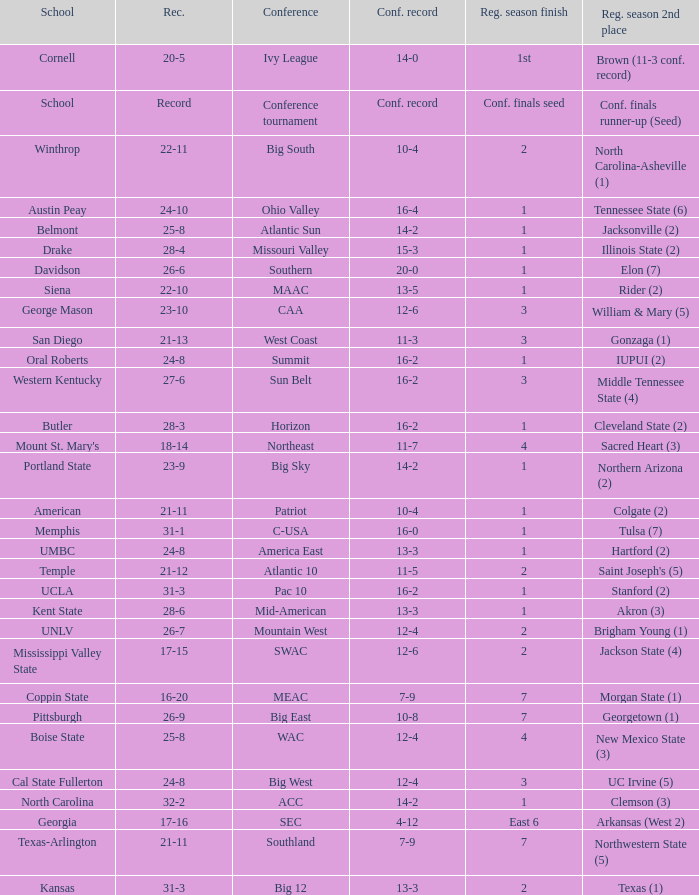For teams in the Sun Belt conference, what is the conference record? 16-2. Parse the full table. {'header': ['School', 'Rec.', 'Conference', 'Conf. record', 'Reg. season finish', 'Reg. season 2nd place'], 'rows': [['Cornell', '20-5', 'Ivy League', '14-0', '1st', 'Brown (11-3 conf. record)'], ['School', 'Record', 'Conference tournament', 'Conf. record', 'Conf. finals seed', 'Conf. finals runner-up (Seed)'], ['Winthrop', '22-11', 'Big South', '10-4', '2', 'North Carolina-Asheville (1)'], ['Austin Peay', '24-10', 'Ohio Valley', '16-4', '1', 'Tennessee State (6)'], ['Belmont', '25-8', 'Atlantic Sun', '14-2', '1', 'Jacksonville (2)'], ['Drake', '28-4', 'Missouri Valley', '15-3', '1', 'Illinois State (2)'], ['Davidson', '26-6', 'Southern', '20-0', '1', 'Elon (7)'], ['Siena', '22-10', 'MAAC', '13-5', '1', 'Rider (2)'], ['George Mason', '23-10', 'CAA', '12-6', '3', 'William & Mary (5)'], ['San Diego', '21-13', 'West Coast', '11-3', '3', 'Gonzaga (1)'], ['Oral Roberts', '24-8', 'Summit', '16-2', '1', 'IUPUI (2)'], ['Western Kentucky', '27-6', 'Sun Belt', '16-2', '3', 'Middle Tennessee State (4)'], ['Butler', '28-3', 'Horizon', '16-2', '1', 'Cleveland State (2)'], ["Mount St. Mary's", '18-14', 'Northeast', '11-7', '4', 'Sacred Heart (3)'], ['Portland State', '23-9', 'Big Sky', '14-2', '1', 'Northern Arizona (2)'], ['American', '21-11', 'Patriot', '10-4', '1', 'Colgate (2)'], ['Memphis', '31-1', 'C-USA', '16-0', '1', 'Tulsa (7)'], ['UMBC', '24-8', 'America East', '13-3', '1', 'Hartford (2)'], ['Temple', '21-12', 'Atlantic 10', '11-5', '2', "Saint Joseph's (5)"], ['UCLA', '31-3', 'Pac 10', '16-2', '1', 'Stanford (2)'], ['Kent State', '28-6', 'Mid-American', '13-3', '1', 'Akron (3)'], ['UNLV', '26-7', 'Mountain West', '12-4', '2', 'Brigham Young (1)'], ['Mississippi Valley State', '17-15', 'SWAC', '12-6', '2', 'Jackson State (4)'], ['Coppin State', '16-20', 'MEAC', '7-9', '7', 'Morgan State (1)'], ['Pittsburgh', '26-9', 'Big East', '10-8', '7', 'Georgetown (1)'], ['Boise State', '25-8', 'WAC', '12-4', '4', 'New Mexico State (3)'], ['Cal State Fullerton', '24-8', 'Big West', '12-4', '3', 'UC Irvine (5)'], ['North Carolina', '32-2', 'ACC', '14-2', '1', 'Clemson (3)'], ['Georgia', '17-16', 'SEC', '4-12', 'East 6', 'Arkansas (West 2)'], ['Texas-Arlington', '21-11', 'Southland', '7-9', '7', 'Northwestern State (5)'], ['Kansas', '31-3', 'Big 12', '13-3', '2', 'Texas (1)']]} 